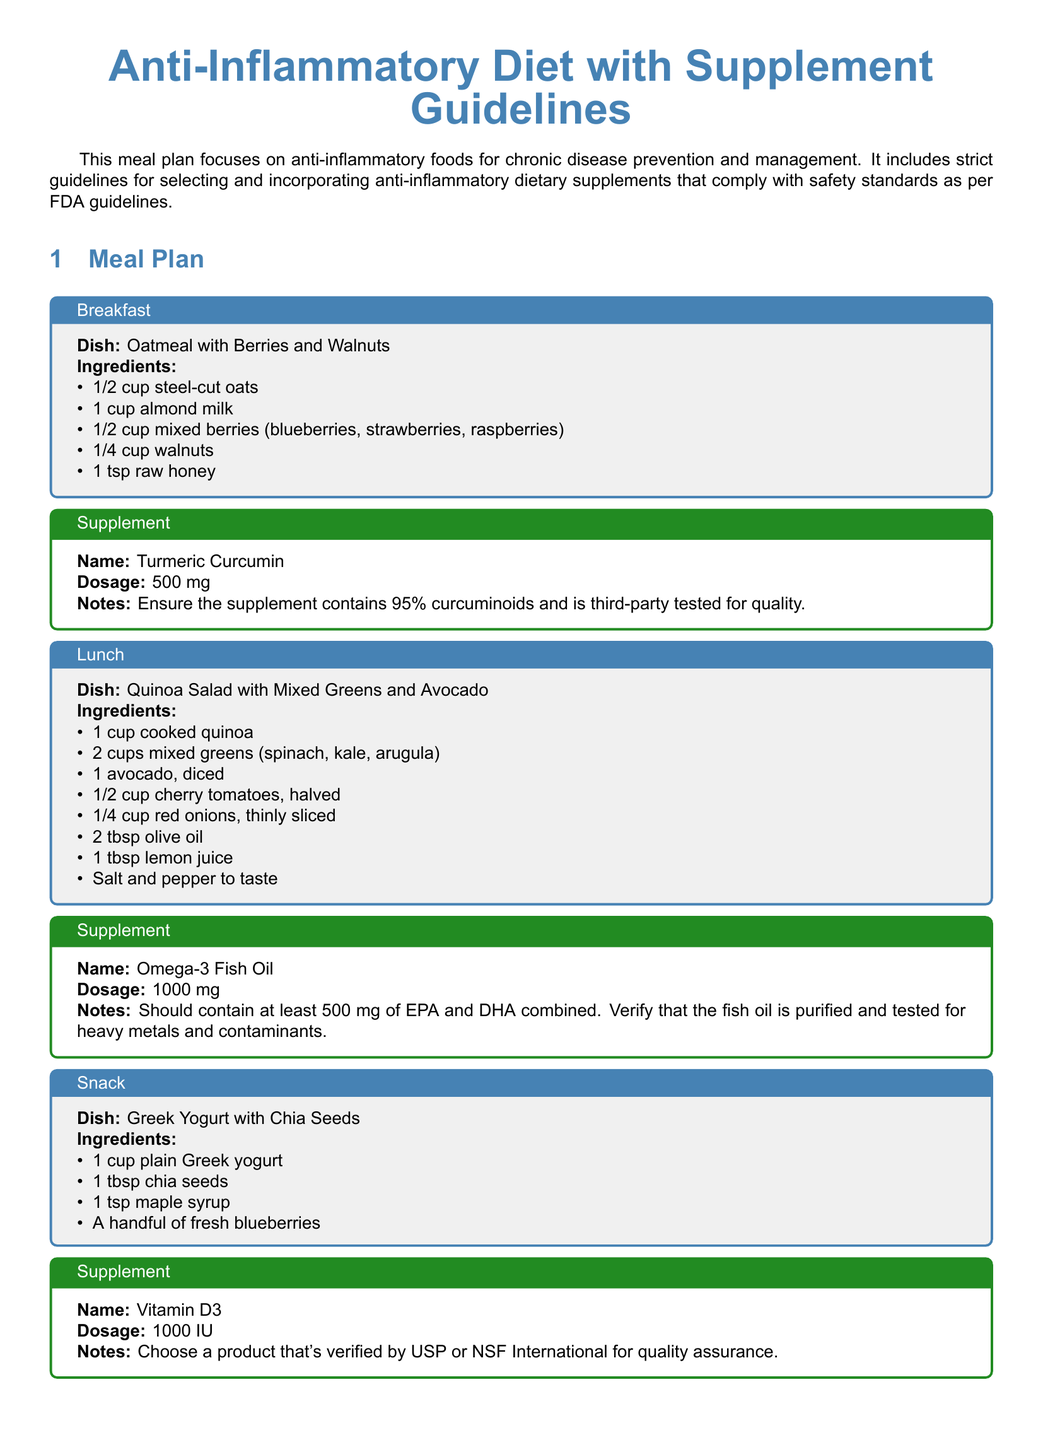What does the breakfast meal consist of? The breakfast meal is described with ingredients including steel-cut oats, almond milk, mixed berries, walnuts, and raw honey.
Answer: Oatmeal with Berries and Walnuts What is the dosage for Turmeric Curcumin? The document specifies that the dosage for Turmeric Curcumin is 500 mg.
Answer: 500 mg How many cups of mixed greens are in the lunch meal? The lunch meal contains 2 cups of mixed greens, which includes spinach, kale, and arugula.
Answer: 2 cups What should Omega-3 Fish Oil contain? The guideline mentions that Omega-3 Fish Oil should contain at least 500 mg of EPA and DHA combined.
Answer: At least 500 mg of EPA and DHA Which supplement is advised for quality assurance verified by USP or NSF International? The document states that Vitamin D3 should be verified by USP or NSF International for quality assurance.
Answer: Vitamin D3 What types of foods should be prioritized in the diet? The document recommends prioritizing whole, unprocessed foods such as fruits, vegetables, nuts, seeds, whole grains, and lean proteins.
Answer: Whole, unprocessed foods What is a key guideline when selecting supplements? A key guideline states that all supplements should be third-party tested for quality, potency, and safety.
Answer: Third-party tested How many ingredients are listed for the snack? The snack consists of 4 ingredients: plain Greek yogurt, chia seeds, maple syrup, and fresh blueberries.
Answer: 4 ingredients What is the recommended standard for the extract in Ginger Extract? The document specifies that Ginger Extract should contain 5% gingerols and be certified for purity and potency.
Answer: 5% gingerols 